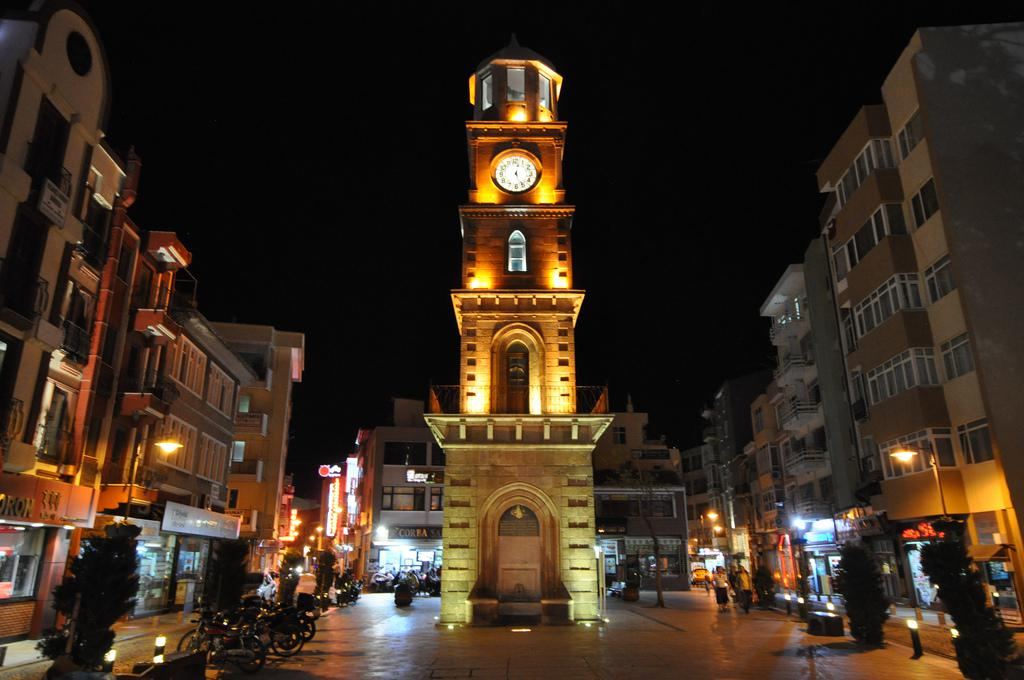Question: when is this?
Choices:
A. Night time.
B. During the last hurricane.
C. Sunday during worship services.
D. Before the election.
Answer with the letter. Answer: A Question: what color is the clock tower?
Choices:
A. White.
B. Yellow.
C. Black.
D. Dirty brown due to pollution.
Answer with the letter. Answer: B Question: what mode of transportation is visible?
Choices:
A. Automobiles.
B. Bicycles.
C. All types, only Wonder Woman has an invisible airplane.
D. Airplanes.
Answer with the letter. Answer: B Question: what are the people doing?
Choices:
A. Running.
B. Walking.
C. Skiing.
D. Laying on the beach.
Answer with the letter. Answer: B Question: how many stories are the buildings on the right?
Choices:
A. 3.
B. 4.
C. 6.
D. 5.
Answer with the letter. Answer: C Question: what is at the top of the tower?
Choices:
A. Flashing lights.
B. A weather pole.
C. The water container.
D. Windows.
Answer with the letter. Answer: D Question: what is the lady carrying?
Choices:
A. Her baby.
B. A bag.
C. Her wallet.
D. The trash.
Answer with the letter. Answer: B Question: where are people walking?
Choices:
A. Down the trail.
B. Up the road.
C. Into town.
D. On the street.
Answer with the letter. Answer: D Question: how does the clock look?
Choices:
A. Lit up.
B. Broken.
C. Unused.
D. Brand new.
Answer with the letter. Answer: A Question: how does the tower look?
Choices:
A. Dark and scary.
B. Brightly lit.
C. Dim and empty.
D. Freshly painted.
Answer with the letter. Answer: B Question: what are lined up on the side of the street?
Choices:
A. Bicycles.
B. Scooters.
C. Skateboards.
D. Tricycles.
Answer with the letter. Answer: A Question: how is the sky?
Choices:
A. Very dark.
B. Bright blue.
C. Gray.
D. Sunny.
Answer with the letter. Answer: A Question: what are on the bike racks?
Choices:
A. Chains.
B. Locks.
C. Bicycles.
D. Helmets.
Answer with the letter. Answer: C 